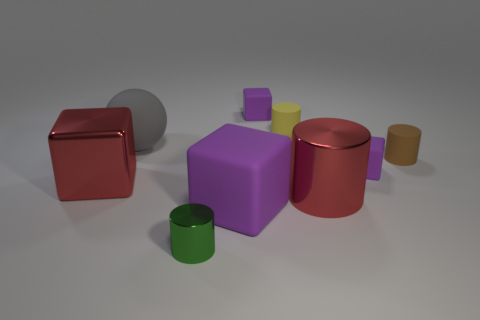Subtract all purple cubes. How many were subtracted if there are1purple cubes left? 2 Add 1 tiny purple blocks. How many objects exist? 10 Subtract all large metal cylinders. How many cylinders are left? 3 Subtract all cubes. How many objects are left? 5 Subtract 1 cylinders. How many cylinders are left? 3 Subtract all cyan spheres. How many purple blocks are left? 3 Subtract all red blocks. How many blocks are left? 3 Subtract 0 cyan blocks. How many objects are left? 9 Subtract all green blocks. Subtract all yellow balls. How many blocks are left? 4 Subtract all red things. Subtract all blocks. How many objects are left? 3 